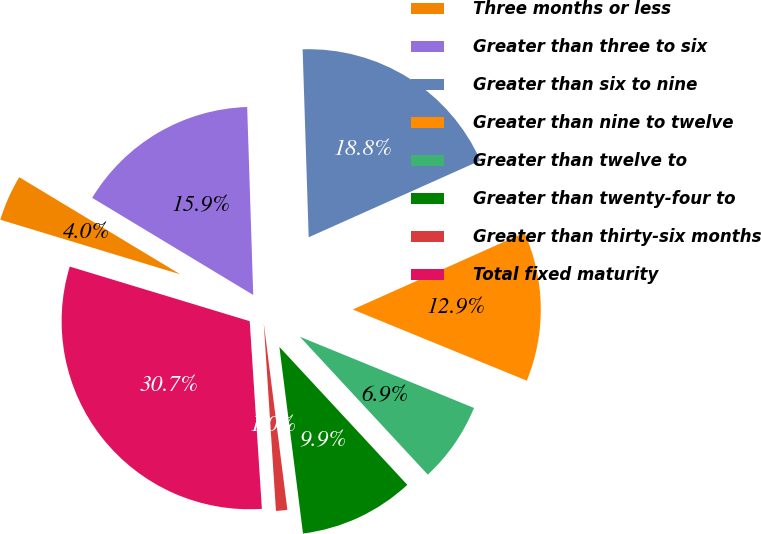<chart> <loc_0><loc_0><loc_500><loc_500><pie_chart><fcel>Three months or less<fcel>Greater than three to six<fcel>Greater than six to nine<fcel>Greater than nine to twelve<fcel>Greater than twelve to<fcel>Greater than twenty-four to<fcel>Greater than thirty-six months<fcel>Total fixed maturity<nl><fcel>3.95%<fcel>15.85%<fcel>18.82%<fcel>12.87%<fcel>6.92%<fcel>9.9%<fcel>0.97%<fcel>30.72%<nl></chart> 